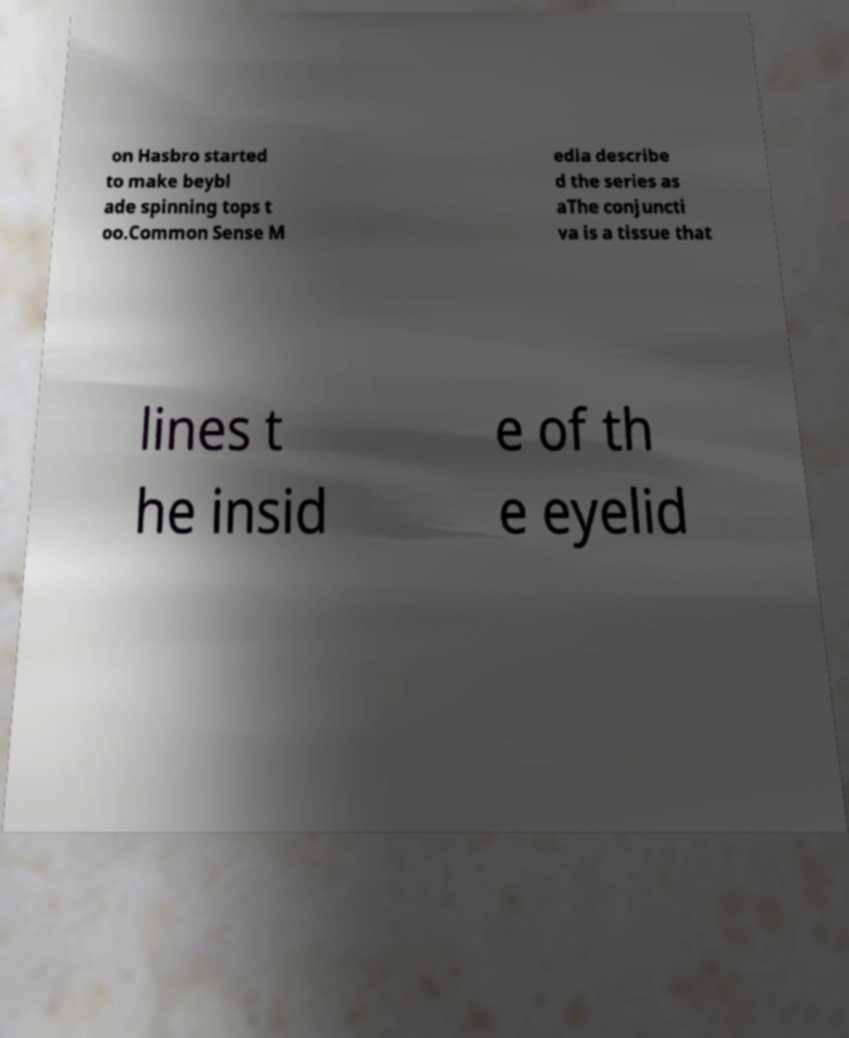Can you read and provide the text displayed in the image?This photo seems to have some interesting text. Can you extract and type it out for me? on Hasbro started to make beybl ade spinning tops t oo.Common Sense M edia describe d the series as aThe conjuncti va is a tissue that lines t he insid e of th e eyelid 